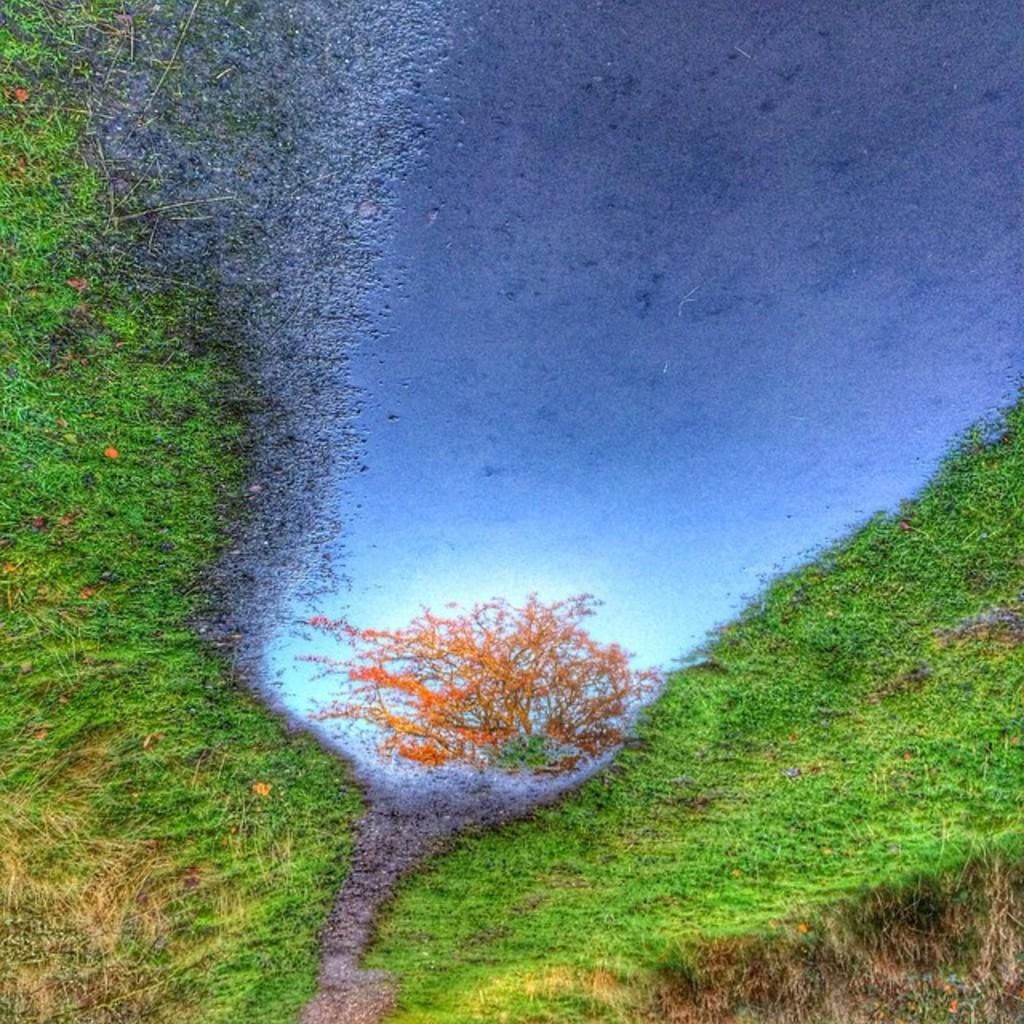What type of vegetation is present in the image? There is grass in the image. What natural element is also visible in the image? There is water in the image. What does the water reflect in the image? The water reflects a tree and the sky in the image. How many cans are visible in the image? There are no cans present in the image. Is there a baby playing with bikes in the image? There is no baby or bikes present in the image. 